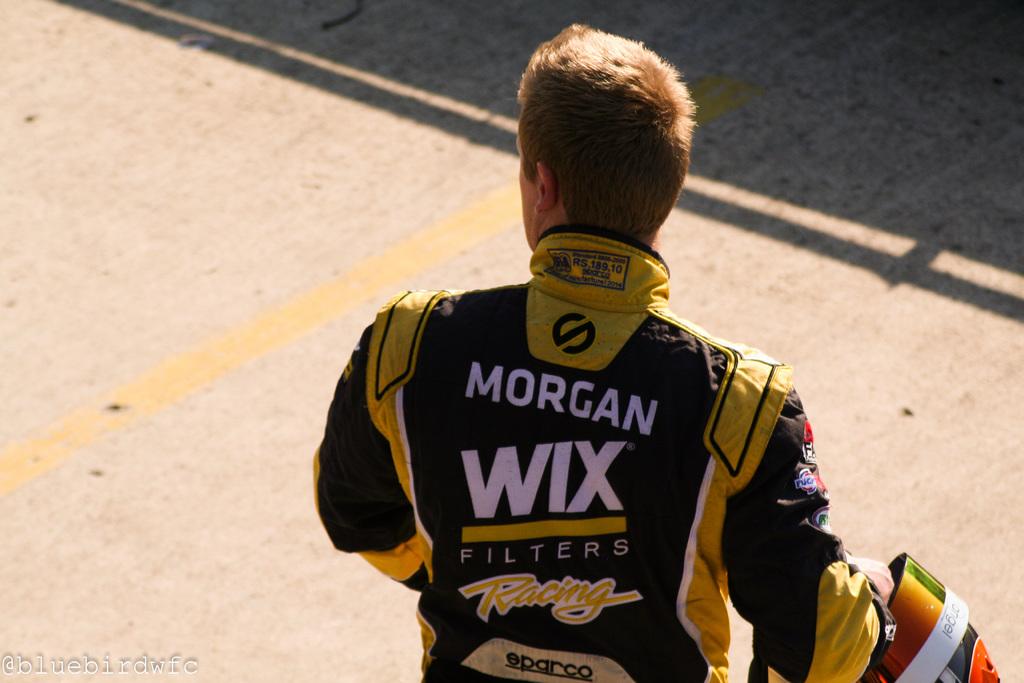What is the man's name?
Your answer should be very brief. Morgan. 